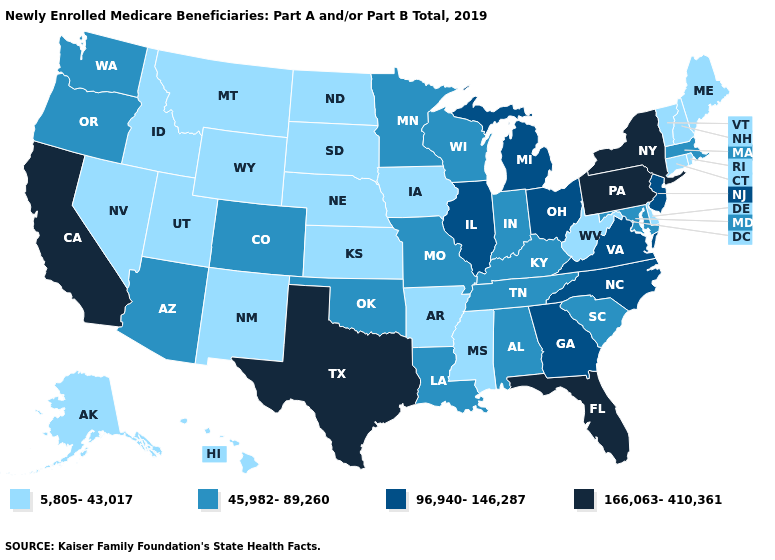Does Alabama have the lowest value in the South?
Be succinct. No. Does Pennsylvania have the highest value in the USA?
Answer briefly. Yes. What is the highest value in the MidWest ?
Give a very brief answer. 96,940-146,287. Name the states that have a value in the range 166,063-410,361?
Be succinct. California, Florida, New York, Pennsylvania, Texas. What is the highest value in the Northeast ?
Give a very brief answer. 166,063-410,361. Does Nebraska have a lower value than Georgia?
Short answer required. Yes. What is the lowest value in the USA?
Concise answer only. 5,805-43,017. Does the map have missing data?
Quick response, please. No. Name the states that have a value in the range 45,982-89,260?
Keep it brief. Alabama, Arizona, Colorado, Indiana, Kentucky, Louisiana, Maryland, Massachusetts, Minnesota, Missouri, Oklahoma, Oregon, South Carolina, Tennessee, Washington, Wisconsin. What is the value of Arkansas?
Answer briefly. 5,805-43,017. What is the lowest value in the USA?
Be succinct. 5,805-43,017. What is the lowest value in the Northeast?
Keep it brief. 5,805-43,017. Name the states that have a value in the range 5,805-43,017?
Short answer required. Alaska, Arkansas, Connecticut, Delaware, Hawaii, Idaho, Iowa, Kansas, Maine, Mississippi, Montana, Nebraska, Nevada, New Hampshire, New Mexico, North Dakota, Rhode Island, South Dakota, Utah, Vermont, West Virginia, Wyoming. Which states have the highest value in the USA?
Be succinct. California, Florida, New York, Pennsylvania, Texas. What is the highest value in the USA?
Keep it brief. 166,063-410,361. 